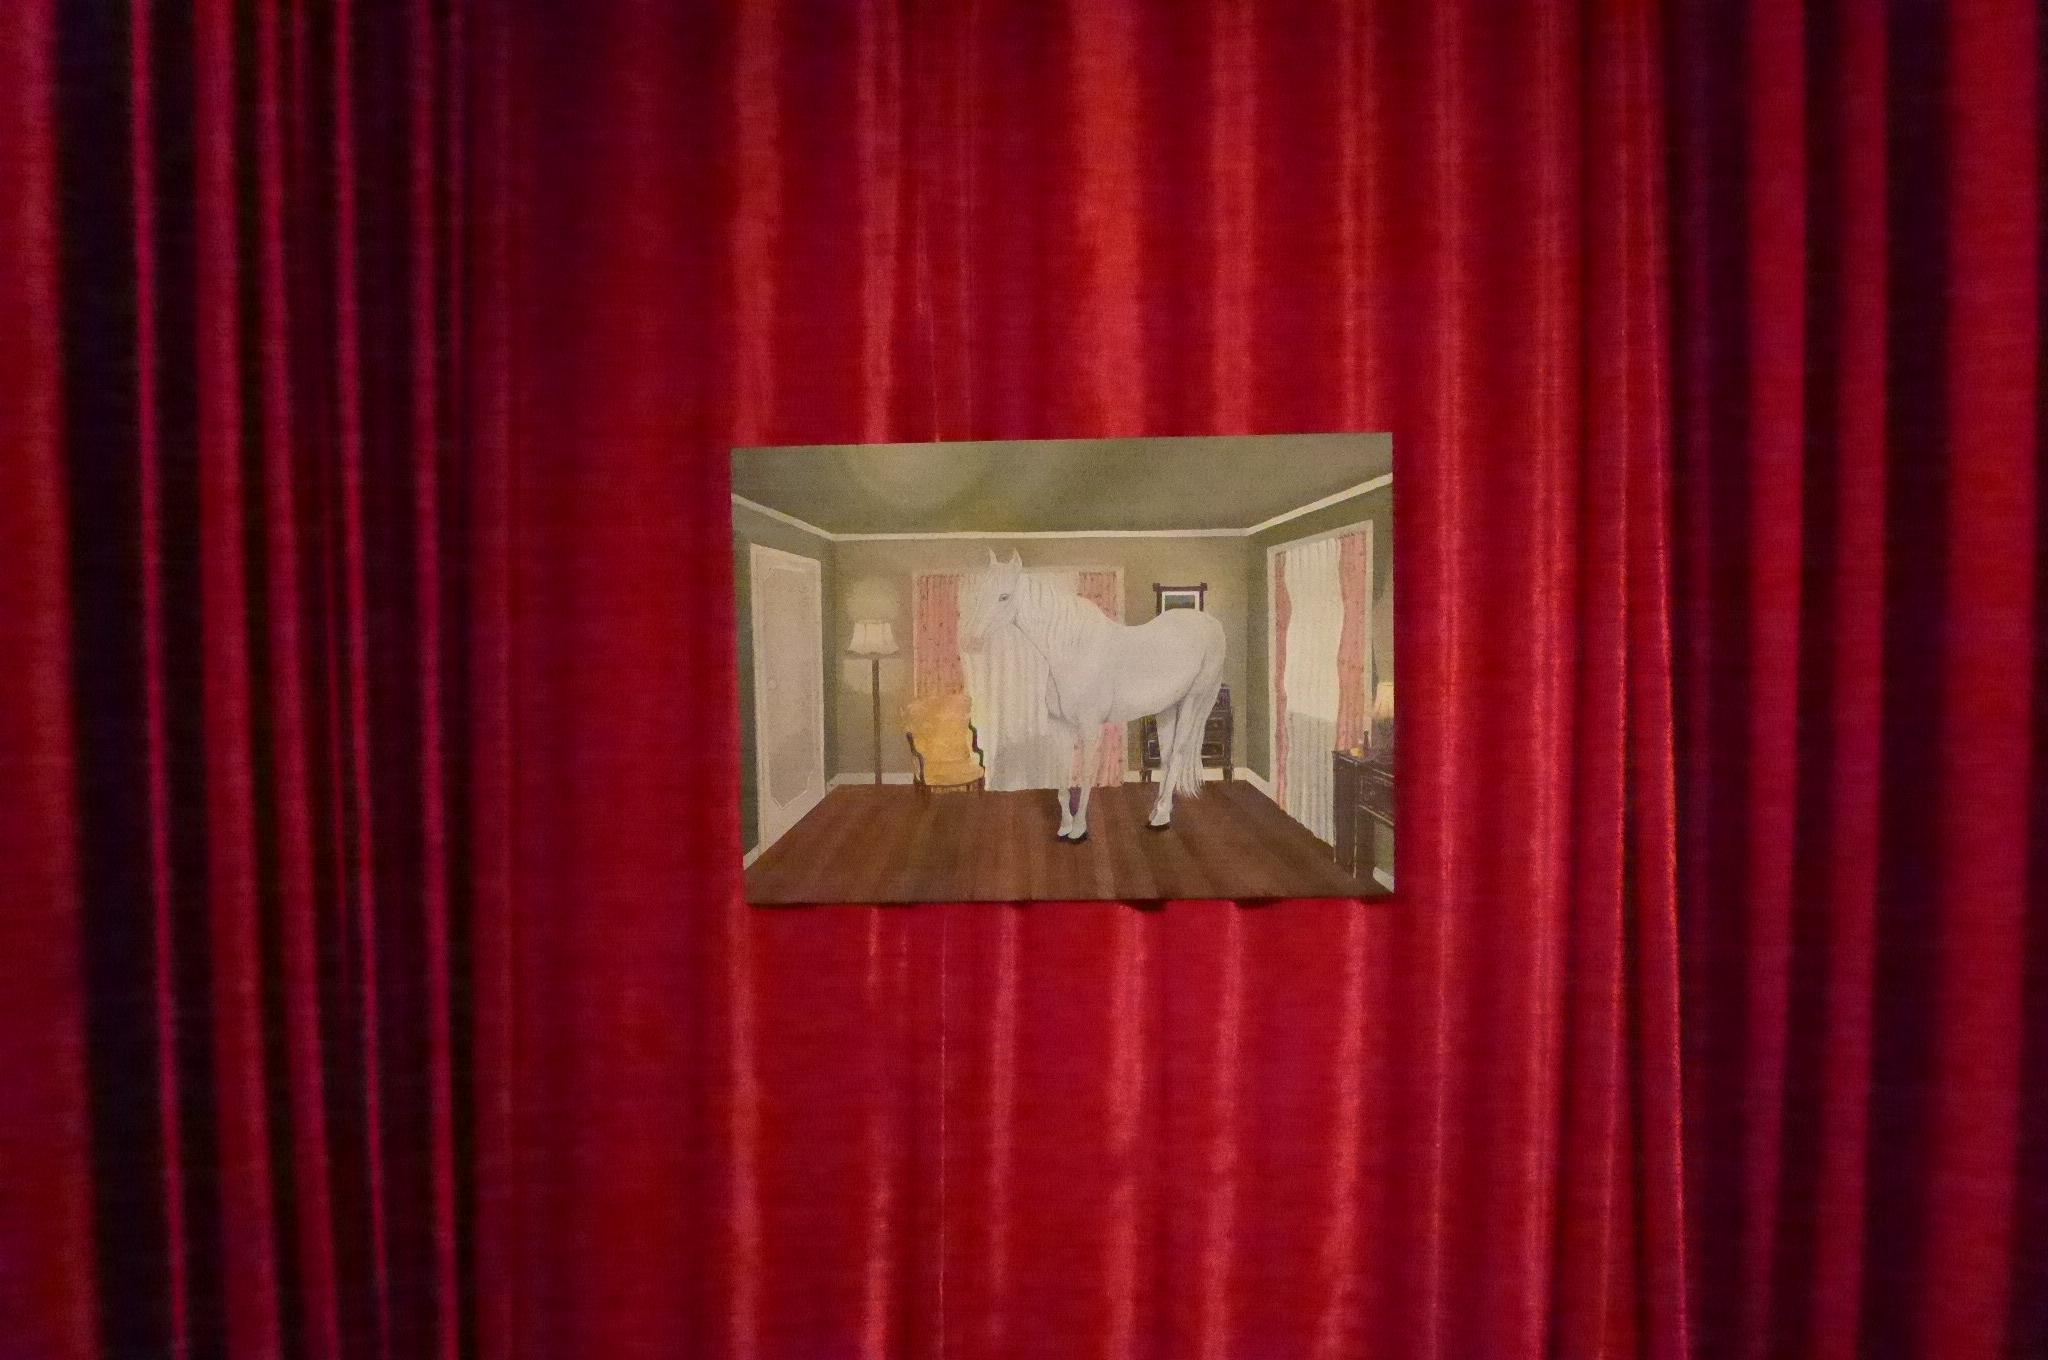What is the main subject of the image? There is a photograph in the image. What can be seen in the photograph? The photograph contains an image of a horse, a chair, a lamp, a floor, walls, a frame, and a roof. What is present in the image besides the photograph? There is a curtain in the image. What type of dinner is being served in the image? There is no dinner present in the image; it contains a photograph of various objects and elements. Can you describe the horse's behavior during the chair's dinner in the image? There is no horse or chair dinner present in the image; it contains a photograph of various objects and elements. 